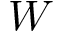<formula> <loc_0><loc_0><loc_500><loc_500>W</formula> 